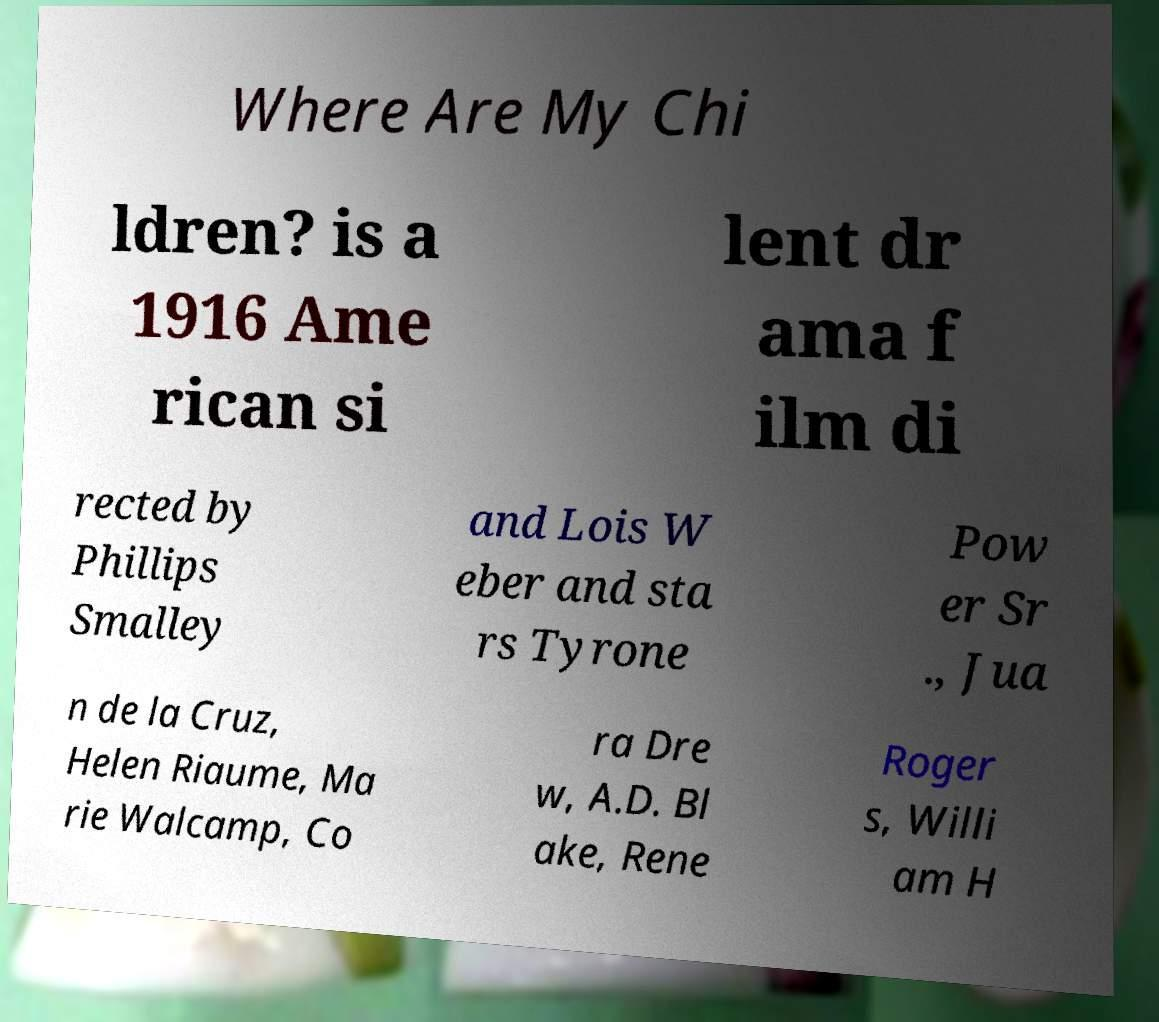I need the written content from this picture converted into text. Can you do that? Where Are My Chi ldren? is a 1916 Ame rican si lent dr ama f ilm di rected by Phillips Smalley and Lois W eber and sta rs Tyrone Pow er Sr ., Jua n de la Cruz, Helen Riaume, Ma rie Walcamp, Co ra Dre w, A.D. Bl ake, Rene Roger s, Willi am H 